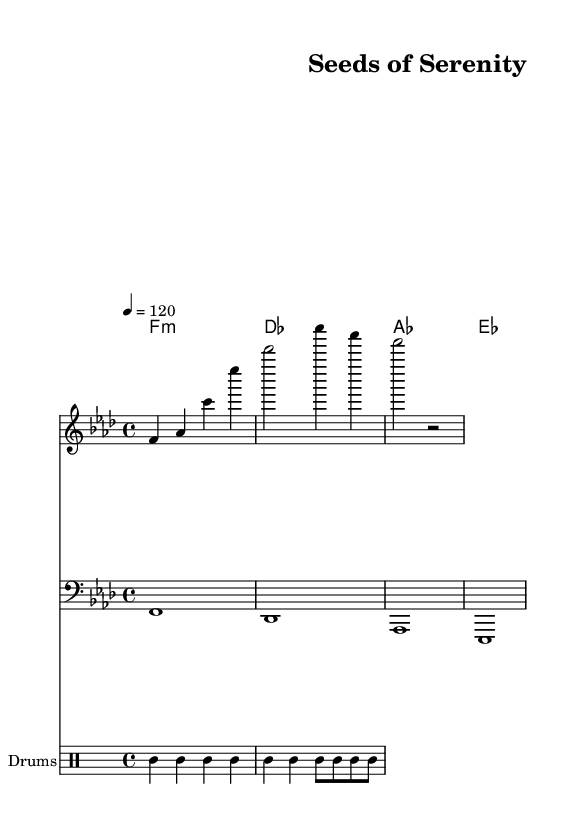What is the key signature of this music? The key signature is F minor, which has four flats (B♭, E♭, A♭, D♭). We can determine this from the key signature indicated at the beginning of the staff.
Answer: F minor What is the time signature of this music? The time signature is 4/4, which indicates that there are four beats in a measure, and the quarter note gets one beat. This is displayed at the beginning of the piece, right after the key signature.
Answer: 4/4 What is the tempo marking of this piece? The tempo marking of this piece is 120 beats per minute, indicated at the beginning of the score after the time signature. This tells performers how fast to play the music.
Answer: 120 How many measures are in the melody? The melody consists of three measures, which can be counted visually in the staff, with bar lines separating them. Each measure holds a specific number of beats indicated by the time signature.
Answer: 3 What type of drums are used in this composition? The composition utilizes bass drum, snare drum, and hi-hat, as indicated in the drums section with their respective pitch names. The style reflects typical elements in house music.
Answer: Bass drum, snare drum, hi-hat Which chord is played in the first measure of harmony? The first measure of harmony features an F minor chord, as indicated in the chord names below the staff. This contributes to the tonal center of the piece.
Answer: F minor What mood does the title "Seeds of Serenity" suggest in relation to the music? The title "Seeds of Serenity" suggests a calm and meditative mood, which aligns with the soothing soundscape created by the deep house composition. It reflects the peaceful aspects of tending to an organic garden.
Answer: Calm and meditative 